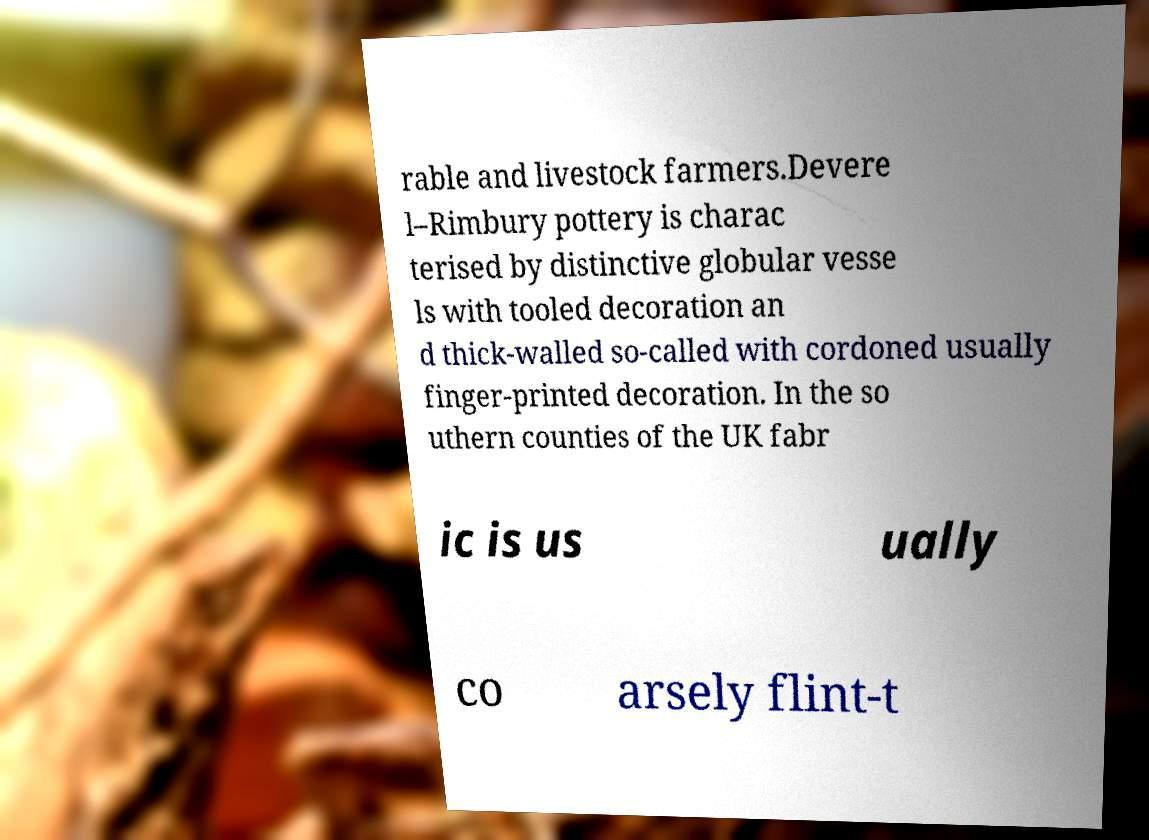For documentation purposes, I need the text within this image transcribed. Could you provide that? rable and livestock farmers.Devere l–Rimbury pottery is charac terised by distinctive globular vesse ls with tooled decoration an d thick-walled so-called with cordoned usually finger-printed decoration. In the so uthern counties of the UK fabr ic is us ually co arsely flint-t 